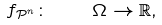Convert formula to latex. <formula><loc_0><loc_0><loc_500><loc_500>f _ { \mathcal { P } ^ { n } } \colon \quad \Omega \rightarrow \mathbb { R } ,</formula> 